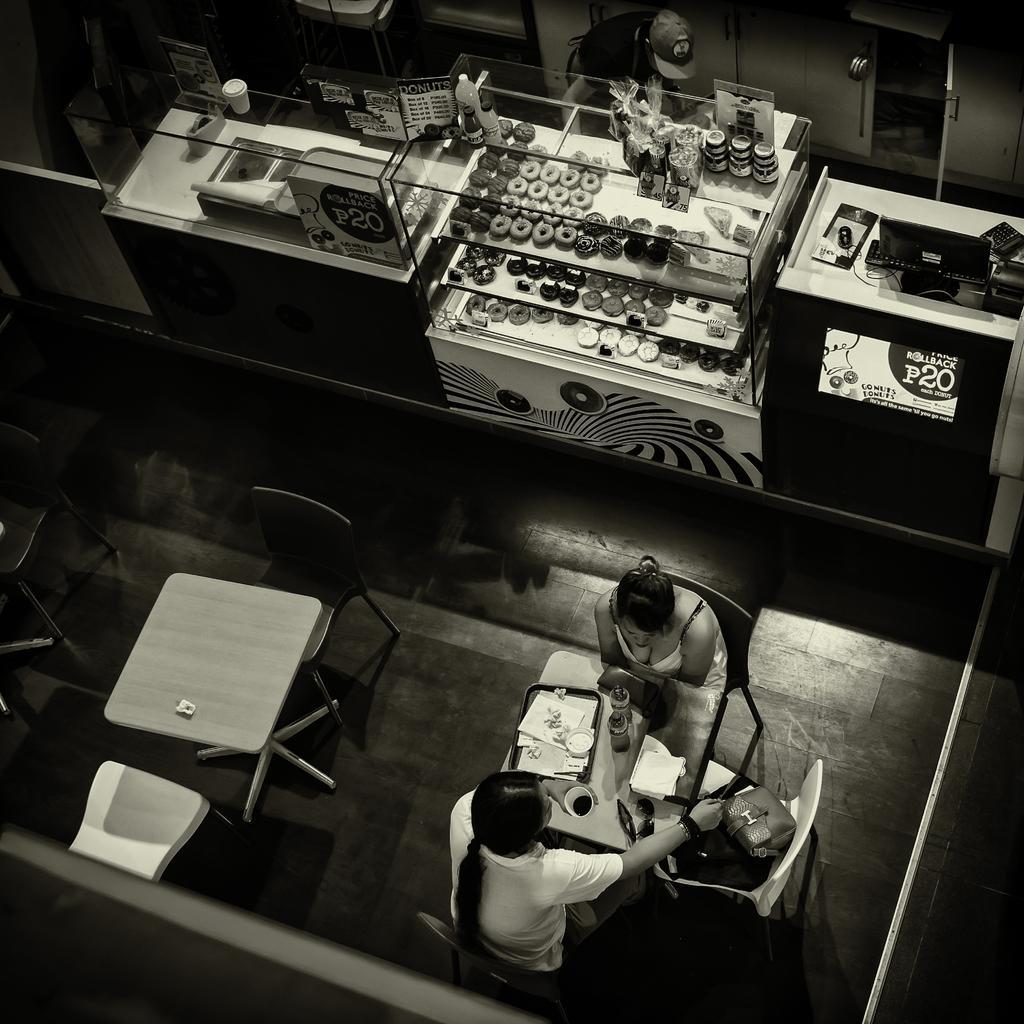Can you describe this image briefly? This is a black and white image. In this image we can see persons sitting on the chairs and a table is placed in front of them. On the table there are serving plate with food in it, tissue papers and a beverage tumbler. In the background there are food items of different kinds arranged in the shelves, desktop, beverage bottles and cartons. 